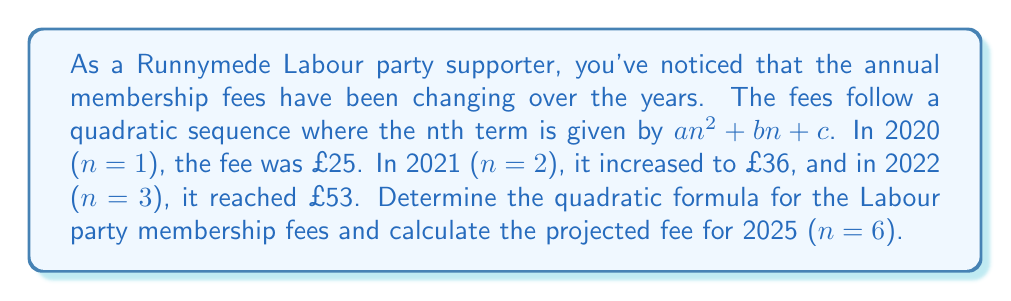Provide a solution to this math problem. To solve this problem, we need to follow these steps:

1) The general form of a quadratic sequence is $an^2 + bn + c$, where n is the term number.

2) We have three known points:
   (1, 25), (2, 36), and (3, 53)

3) Let's substitute these into the general formula:
   $a(1)^2 + b(1) + c = 25$
   $a(2)^2 + b(2) + c = 36$
   $a(3)^2 + b(3) + c = 53$

4) Simplify:
   $a + b + c = 25$ ... (Equation 1)
   $4a + 2b + c = 36$ ... (Equation 2)
   $9a + 3b + c = 53$ ... (Equation 3)

5) Subtract Equation 1 from Equation 2:
   $3a + b = 11$ ... (Equation 4)

6) Subtract Equation 2 from Equation 3:
   $5a + b = 17$ ... (Equation 5)

7) Subtract Equation 4 from Equation 5:
   $2a = 6$
   $a = 3$

8) Substitute $a = 3$ into Equation 4:
   $9 + b = 11$
   $b = 2$

9) Substitute $a = 3$ and $b = 2$ into Equation 1:
   $3 + 2 + c = 25$
   $c = 20$

10) Therefore, the quadratic formula is:
    $3n^2 + 2n + 20$

11) To find the fee for 2025 (n = 6), substitute n = 6:
    $3(6)^2 + 2(6) + 20 = 3(36) + 12 + 20 = 108 + 12 + 20 = 140$

Therefore, the projected fee for 2025 is £140.
Answer: $3n^2 + 2n + 20$; £140 